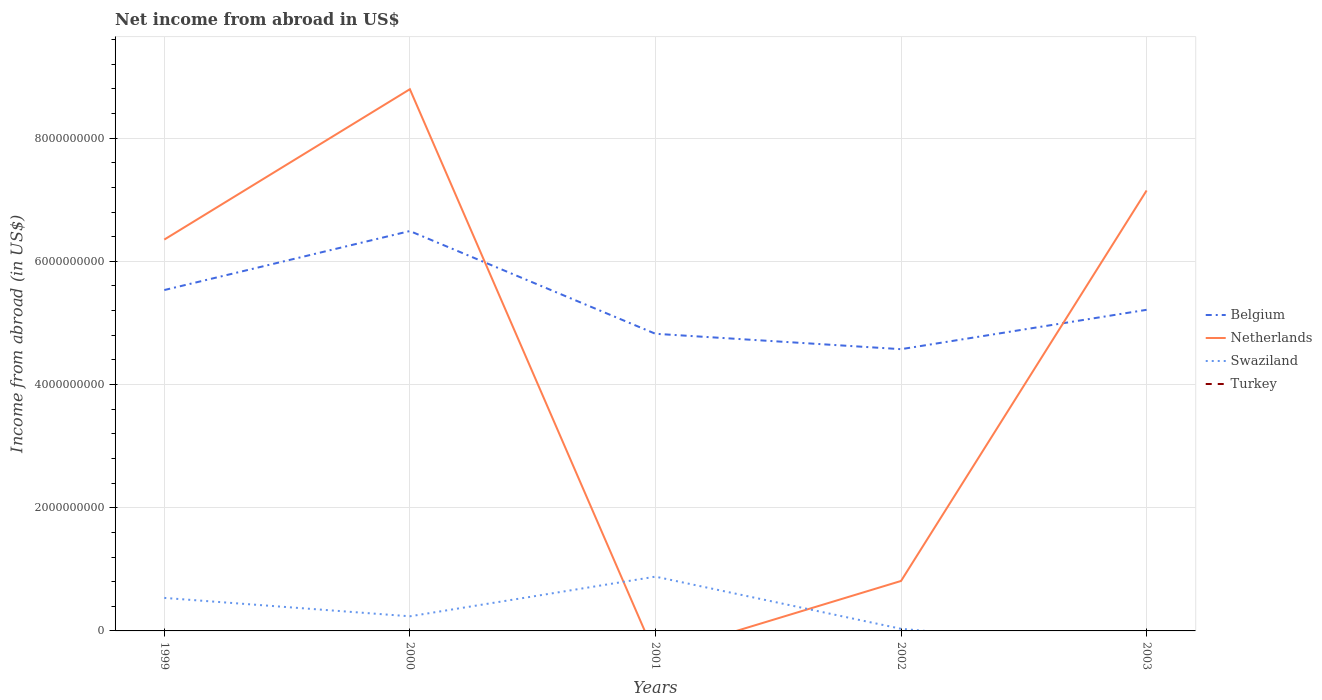How many different coloured lines are there?
Provide a succinct answer. 3. Does the line corresponding to Belgium intersect with the line corresponding to Turkey?
Your answer should be compact. No. Is the number of lines equal to the number of legend labels?
Your response must be concise. No. Across all years, what is the maximum net income from abroad in Swaziland?
Your answer should be compact. 0. What is the total net income from abroad in Belgium in the graph?
Keep it short and to the point. 3.21e+08. What is the difference between the highest and the second highest net income from abroad in Swaziland?
Give a very brief answer. 8.81e+08. What is the difference between the highest and the lowest net income from abroad in Belgium?
Give a very brief answer. 2. Are the values on the major ticks of Y-axis written in scientific E-notation?
Keep it short and to the point. No. Does the graph contain grids?
Provide a short and direct response. Yes. Where does the legend appear in the graph?
Offer a very short reply. Center right. How many legend labels are there?
Your answer should be compact. 4. How are the legend labels stacked?
Provide a succinct answer. Vertical. What is the title of the graph?
Make the answer very short. Net income from abroad in US$. Does "Guam" appear as one of the legend labels in the graph?
Offer a terse response. No. What is the label or title of the Y-axis?
Offer a very short reply. Income from abroad (in US$). What is the Income from abroad (in US$) in Belgium in 1999?
Give a very brief answer. 5.53e+09. What is the Income from abroad (in US$) in Netherlands in 1999?
Provide a succinct answer. 6.35e+09. What is the Income from abroad (in US$) of Swaziland in 1999?
Offer a very short reply. 5.36e+08. What is the Income from abroad (in US$) in Turkey in 1999?
Offer a terse response. 0. What is the Income from abroad (in US$) of Belgium in 2000?
Offer a very short reply. 6.49e+09. What is the Income from abroad (in US$) in Netherlands in 2000?
Give a very brief answer. 8.79e+09. What is the Income from abroad (in US$) in Swaziland in 2000?
Your response must be concise. 2.37e+08. What is the Income from abroad (in US$) of Belgium in 2001?
Ensure brevity in your answer.  4.82e+09. What is the Income from abroad (in US$) in Swaziland in 2001?
Your response must be concise. 8.81e+08. What is the Income from abroad (in US$) in Belgium in 2002?
Your answer should be compact. 4.57e+09. What is the Income from abroad (in US$) of Netherlands in 2002?
Your response must be concise. 8.11e+08. What is the Income from abroad (in US$) of Swaziland in 2002?
Offer a terse response. 3.44e+07. What is the Income from abroad (in US$) in Turkey in 2002?
Provide a short and direct response. 0. What is the Income from abroad (in US$) of Belgium in 2003?
Keep it short and to the point. 5.21e+09. What is the Income from abroad (in US$) in Netherlands in 2003?
Offer a very short reply. 7.15e+09. Across all years, what is the maximum Income from abroad (in US$) in Belgium?
Your answer should be very brief. 6.49e+09. Across all years, what is the maximum Income from abroad (in US$) of Netherlands?
Provide a succinct answer. 8.79e+09. Across all years, what is the maximum Income from abroad (in US$) in Swaziland?
Offer a terse response. 8.81e+08. Across all years, what is the minimum Income from abroad (in US$) in Belgium?
Offer a terse response. 4.57e+09. Across all years, what is the minimum Income from abroad (in US$) of Netherlands?
Ensure brevity in your answer.  0. Across all years, what is the minimum Income from abroad (in US$) of Swaziland?
Make the answer very short. 0. What is the total Income from abroad (in US$) of Belgium in the graph?
Your answer should be compact. 2.66e+1. What is the total Income from abroad (in US$) of Netherlands in the graph?
Ensure brevity in your answer.  2.31e+1. What is the total Income from abroad (in US$) in Swaziland in the graph?
Keep it short and to the point. 1.69e+09. What is the difference between the Income from abroad (in US$) of Belgium in 1999 and that in 2000?
Provide a short and direct response. -9.58e+08. What is the difference between the Income from abroad (in US$) of Netherlands in 1999 and that in 2000?
Ensure brevity in your answer.  -2.44e+09. What is the difference between the Income from abroad (in US$) of Swaziland in 1999 and that in 2000?
Offer a terse response. 2.99e+08. What is the difference between the Income from abroad (in US$) of Belgium in 1999 and that in 2001?
Provide a succinct answer. 7.10e+08. What is the difference between the Income from abroad (in US$) in Swaziland in 1999 and that in 2001?
Provide a succinct answer. -3.45e+08. What is the difference between the Income from abroad (in US$) of Belgium in 1999 and that in 2002?
Provide a succinct answer. 9.60e+08. What is the difference between the Income from abroad (in US$) in Netherlands in 1999 and that in 2002?
Offer a terse response. 5.54e+09. What is the difference between the Income from abroad (in US$) in Swaziland in 1999 and that in 2002?
Offer a very short reply. 5.02e+08. What is the difference between the Income from abroad (in US$) in Belgium in 1999 and that in 2003?
Ensure brevity in your answer.  3.21e+08. What is the difference between the Income from abroad (in US$) of Netherlands in 1999 and that in 2003?
Your answer should be very brief. -7.97e+08. What is the difference between the Income from abroad (in US$) in Belgium in 2000 and that in 2001?
Offer a very short reply. 1.67e+09. What is the difference between the Income from abroad (in US$) in Swaziland in 2000 and that in 2001?
Offer a terse response. -6.44e+08. What is the difference between the Income from abroad (in US$) in Belgium in 2000 and that in 2002?
Your answer should be compact. 1.92e+09. What is the difference between the Income from abroad (in US$) of Netherlands in 2000 and that in 2002?
Offer a terse response. 7.98e+09. What is the difference between the Income from abroad (in US$) in Swaziland in 2000 and that in 2002?
Your answer should be compact. 2.03e+08. What is the difference between the Income from abroad (in US$) of Belgium in 2000 and that in 2003?
Provide a succinct answer. 1.28e+09. What is the difference between the Income from abroad (in US$) in Netherlands in 2000 and that in 2003?
Your answer should be compact. 1.64e+09. What is the difference between the Income from abroad (in US$) in Belgium in 2001 and that in 2002?
Your answer should be very brief. 2.50e+08. What is the difference between the Income from abroad (in US$) of Swaziland in 2001 and that in 2002?
Provide a succinct answer. 8.47e+08. What is the difference between the Income from abroad (in US$) of Belgium in 2001 and that in 2003?
Offer a terse response. -3.89e+08. What is the difference between the Income from abroad (in US$) of Belgium in 2002 and that in 2003?
Your answer should be compact. -6.39e+08. What is the difference between the Income from abroad (in US$) in Netherlands in 2002 and that in 2003?
Offer a terse response. -6.34e+09. What is the difference between the Income from abroad (in US$) in Belgium in 1999 and the Income from abroad (in US$) in Netherlands in 2000?
Provide a succinct answer. -3.26e+09. What is the difference between the Income from abroad (in US$) of Belgium in 1999 and the Income from abroad (in US$) of Swaziland in 2000?
Your answer should be compact. 5.30e+09. What is the difference between the Income from abroad (in US$) of Netherlands in 1999 and the Income from abroad (in US$) of Swaziland in 2000?
Your response must be concise. 6.12e+09. What is the difference between the Income from abroad (in US$) in Belgium in 1999 and the Income from abroad (in US$) in Swaziland in 2001?
Offer a very short reply. 4.65e+09. What is the difference between the Income from abroad (in US$) of Netherlands in 1999 and the Income from abroad (in US$) of Swaziland in 2001?
Offer a very short reply. 5.47e+09. What is the difference between the Income from abroad (in US$) in Belgium in 1999 and the Income from abroad (in US$) in Netherlands in 2002?
Ensure brevity in your answer.  4.72e+09. What is the difference between the Income from abroad (in US$) of Belgium in 1999 and the Income from abroad (in US$) of Swaziland in 2002?
Your answer should be compact. 5.50e+09. What is the difference between the Income from abroad (in US$) in Netherlands in 1999 and the Income from abroad (in US$) in Swaziland in 2002?
Provide a succinct answer. 6.32e+09. What is the difference between the Income from abroad (in US$) of Belgium in 1999 and the Income from abroad (in US$) of Netherlands in 2003?
Provide a short and direct response. -1.62e+09. What is the difference between the Income from abroad (in US$) of Belgium in 2000 and the Income from abroad (in US$) of Swaziland in 2001?
Make the answer very short. 5.61e+09. What is the difference between the Income from abroad (in US$) of Netherlands in 2000 and the Income from abroad (in US$) of Swaziland in 2001?
Your answer should be compact. 7.91e+09. What is the difference between the Income from abroad (in US$) in Belgium in 2000 and the Income from abroad (in US$) in Netherlands in 2002?
Keep it short and to the point. 5.68e+09. What is the difference between the Income from abroad (in US$) in Belgium in 2000 and the Income from abroad (in US$) in Swaziland in 2002?
Ensure brevity in your answer.  6.46e+09. What is the difference between the Income from abroad (in US$) of Netherlands in 2000 and the Income from abroad (in US$) of Swaziland in 2002?
Your answer should be compact. 8.76e+09. What is the difference between the Income from abroad (in US$) of Belgium in 2000 and the Income from abroad (in US$) of Netherlands in 2003?
Make the answer very short. -6.58e+08. What is the difference between the Income from abroad (in US$) of Belgium in 2001 and the Income from abroad (in US$) of Netherlands in 2002?
Your answer should be very brief. 4.01e+09. What is the difference between the Income from abroad (in US$) of Belgium in 2001 and the Income from abroad (in US$) of Swaziland in 2002?
Offer a terse response. 4.79e+09. What is the difference between the Income from abroad (in US$) in Belgium in 2001 and the Income from abroad (in US$) in Netherlands in 2003?
Your response must be concise. -2.33e+09. What is the difference between the Income from abroad (in US$) of Belgium in 2002 and the Income from abroad (in US$) of Netherlands in 2003?
Give a very brief answer. -2.58e+09. What is the average Income from abroad (in US$) in Belgium per year?
Your answer should be compact. 5.33e+09. What is the average Income from abroad (in US$) in Netherlands per year?
Ensure brevity in your answer.  4.62e+09. What is the average Income from abroad (in US$) in Swaziland per year?
Your answer should be compact. 3.38e+08. In the year 1999, what is the difference between the Income from abroad (in US$) of Belgium and Income from abroad (in US$) of Netherlands?
Provide a short and direct response. -8.19e+08. In the year 1999, what is the difference between the Income from abroad (in US$) of Belgium and Income from abroad (in US$) of Swaziland?
Your response must be concise. 5.00e+09. In the year 1999, what is the difference between the Income from abroad (in US$) in Netherlands and Income from abroad (in US$) in Swaziland?
Keep it short and to the point. 5.82e+09. In the year 2000, what is the difference between the Income from abroad (in US$) of Belgium and Income from abroad (in US$) of Netherlands?
Your response must be concise. -2.30e+09. In the year 2000, what is the difference between the Income from abroad (in US$) in Belgium and Income from abroad (in US$) in Swaziland?
Ensure brevity in your answer.  6.25e+09. In the year 2000, what is the difference between the Income from abroad (in US$) in Netherlands and Income from abroad (in US$) in Swaziland?
Make the answer very short. 8.56e+09. In the year 2001, what is the difference between the Income from abroad (in US$) in Belgium and Income from abroad (in US$) in Swaziland?
Provide a short and direct response. 3.94e+09. In the year 2002, what is the difference between the Income from abroad (in US$) in Belgium and Income from abroad (in US$) in Netherlands?
Keep it short and to the point. 3.76e+09. In the year 2002, what is the difference between the Income from abroad (in US$) of Belgium and Income from abroad (in US$) of Swaziland?
Provide a succinct answer. 4.54e+09. In the year 2002, what is the difference between the Income from abroad (in US$) in Netherlands and Income from abroad (in US$) in Swaziland?
Your response must be concise. 7.77e+08. In the year 2003, what is the difference between the Income from abroad (in US$) of Belgium and Income from abroad (in US$) of Netherlands?
Your response must be concise. -1.94e+09. What is the ratio of the Income from abroad (in US$) of Belgium in 1999 to that in 2000?
Provide a short and direct response. 0.85. What is the ratio of the Income from abroad (in US$) in Netherlands in 1999 to that in 2000?
Your answer should be compact. 0.72. What is the ratio of the Income from abroad (in US$) of Swaziland in 1999 to that in 2000?
Provide a succinct answer. 2.26. What is the ratio of the Income from abroad (in US$) of Belgium in 1999 to that in 2001?
Your response must be concise. 1.15. What is the ratio of the Income from abroad (in US$) in Swaziland in 1999 to that in 2001?
Offer a terse response. 0.61. What is the ratio of the Income from abroad (in US$) in Belgium in 1999 to that in 2002?
Provide a succinct answer. 1.21. What is the ratio of the Income from abroad (in US$) of Netherlands in 1999 to that in 2002?
Ensure brevity in your answer.  7.83. What is the ratio of the Income from abroad (in US$) in Swaziland in 1999 to that in 2002?
Your answer should be very brief. 15.58. What is the ratio of the Income from abroad (in US$) in Belgium in 1999 to that in 2003?
Ensure brevity in your answer.  1.06. What is the ratio of the Income from abroad (in US$) of Netherlands in 1999 to that in 2003?
Provide a succinct answer. 0.89. What is the ratio of the Income from abroad (in US$) of Belgium in 2000 to that in 2001?
Provide a short and direct response. 1.35. What is the ratio of the Income from abroad (in US$) in Swaziland in 2000 to that in 2001?
Provide a short and direct response. 0.27. What is the ratio of the Income from abroad (in US$) in Belgium in 2000 to that in 2002?
Give a very brief answer. 1.42. What is the ratio of the Income from abroad (in US$) of Netherlands in 2000 to that in 2002?
Provide a succinct answer. 10.84. What is the ratio of the Income from abroad (in US$) in Swaziland in 2000 to that in 2002?
Ensure brevity in your answer.  6.9. What is the ratio of the Income from abroad (in US$) of Belgium in 2000 to that in 2003?
Offer a terse response. 1.25. What is the ratio of the Income from abroad (in US$) in Netherlands in 2000 to that in 2003?
Your answer should be compact. 1.23. What is the ratio of the Income from abroad (in US$) in Belgium in 2001 to that in 2002?
Make the answer very short. 1.05. What is the ratio of the Income from abroad (in US$) in Swaziland in 2001 to that in 2002?
Offer a very short reply. 25.61. What is the ratio of the Income from abroad (in US$) in Belgium in 2001 to that in 2003?
Your answer should be very brief. 0.93. What is the ratio of the Income from abroad (in US$) in Belgium in 2002 to that in 2003?
Offer a terse response. 0.88. What is the ratio of the Income from abroad (in US$) of Netherlands in 2002 to that in 2003?
Offer a terse response. 0.11. What is the difference between the highest and the second highest Income from abroad (in US$) in Belgium?
Your answer should be compact. 9.58e+08. What is the difference between the highest and the second highest Income from abroad (in US$) in Netherlands?
Your response must be concise. 1.64e+09. What is the difference between the highest and the second highest Income from abroad (in US$) of Swaziland?
Keep it short and to the point. 3.45e+08. What is the difference between the highest and the lowest Income from abroad (in US$) in Belgium?
Make the answer very short. 1.92e+09. What is the difference between the highest and the lowest Income from abroad (in US$) of Netherlands?
Your answer should be very brief. 8.79e+09. What is the difference between the highest and the lowest Income from abroad (in US$) in Swaziland?
Offer a terse response. 8.81e+08. 